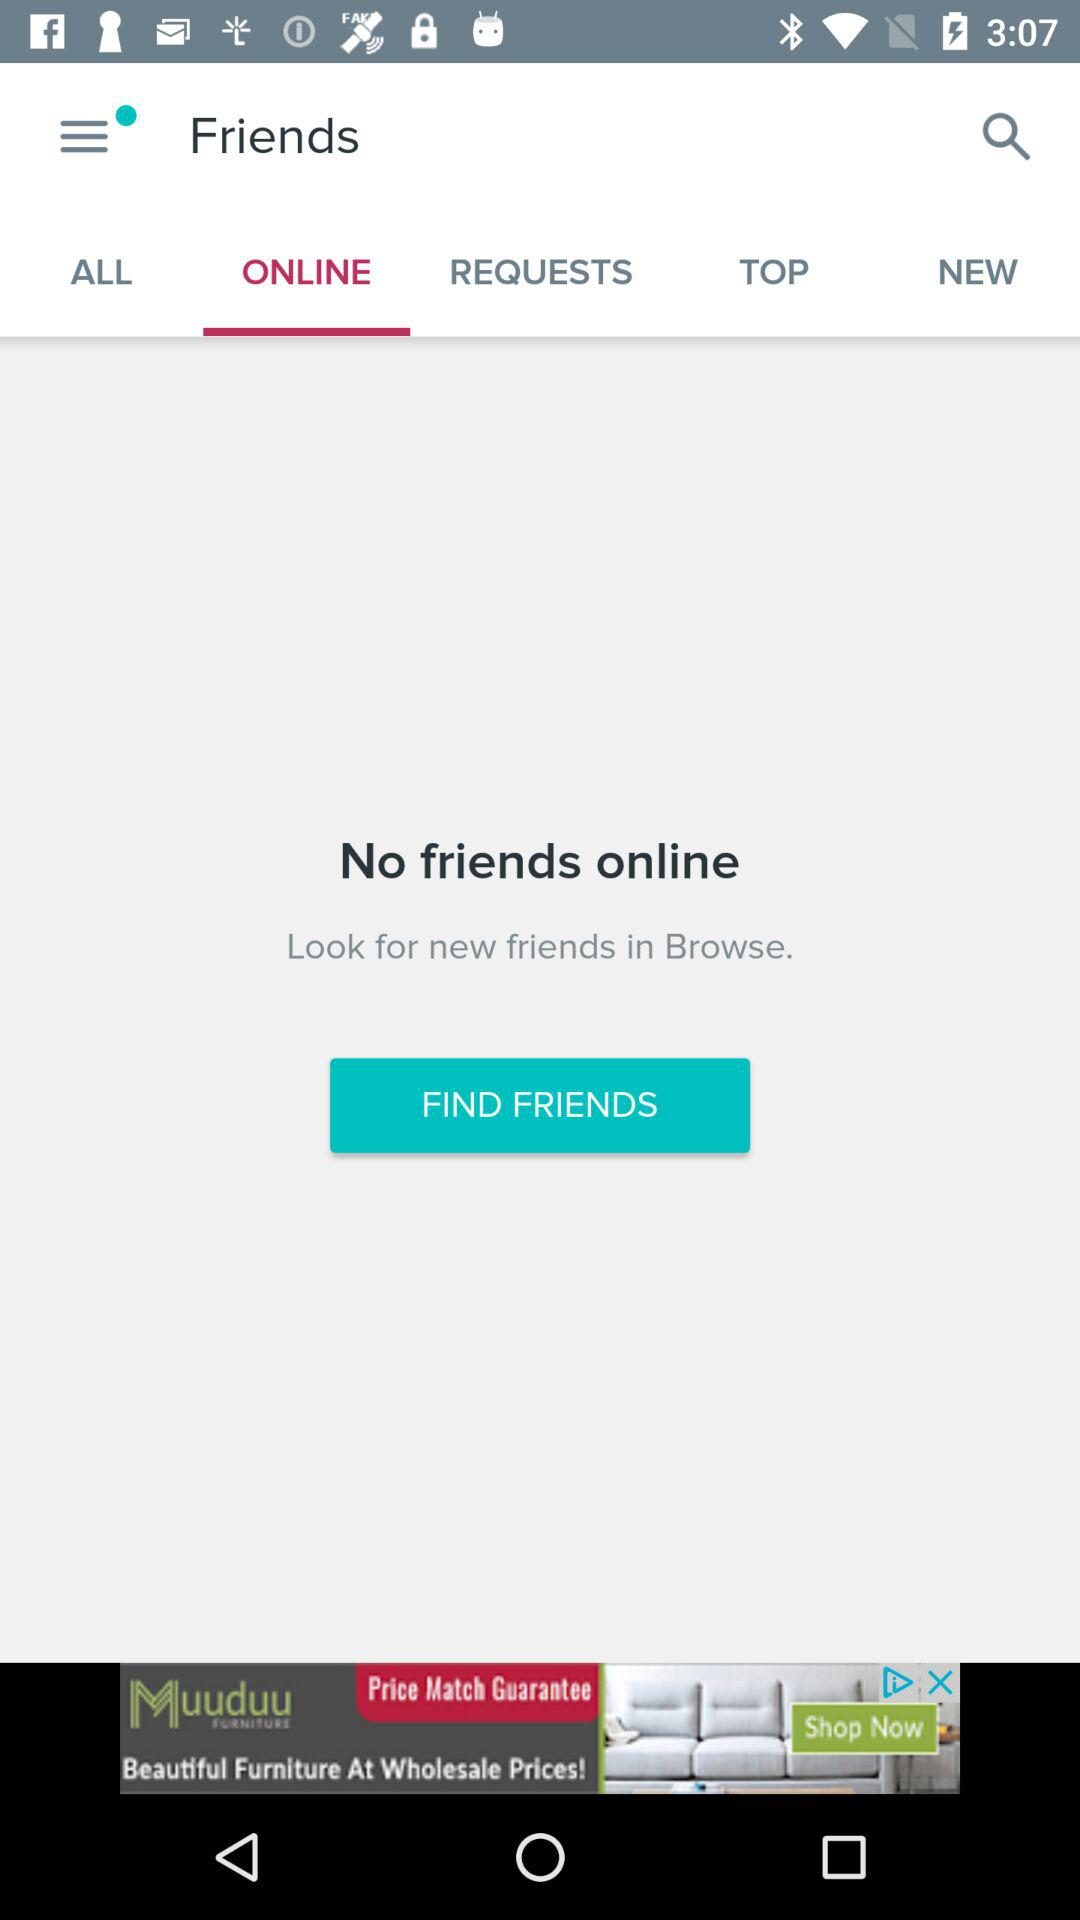How many friends are online?
Answer the question using a single word or phrase. 0 